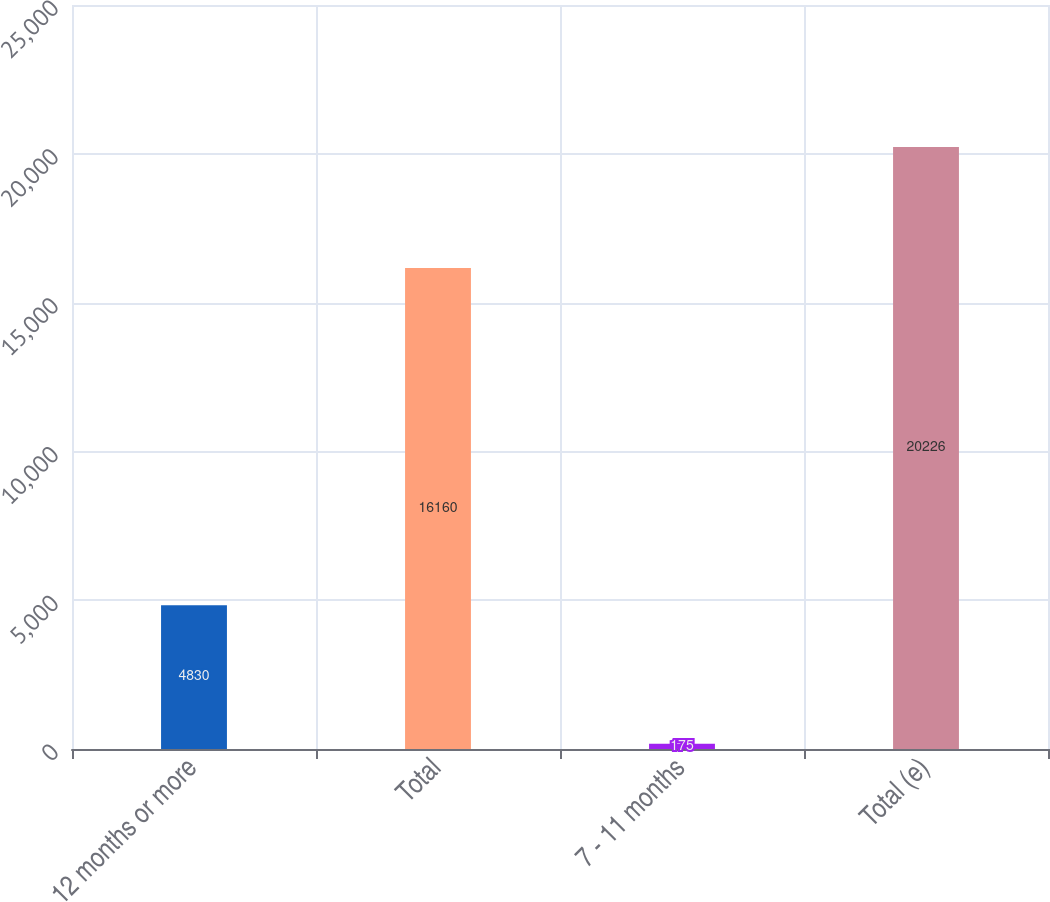<chart> <loc_0><loc_0><loc_500><loc_500><bar_chart><fcel>12 months or more<fcel>Total<fcel>7 - 11 months<fcel>Total (e)<nl><fcel>4830<fcel>16160<fcel>175<fcel>20226<nl></chart> 